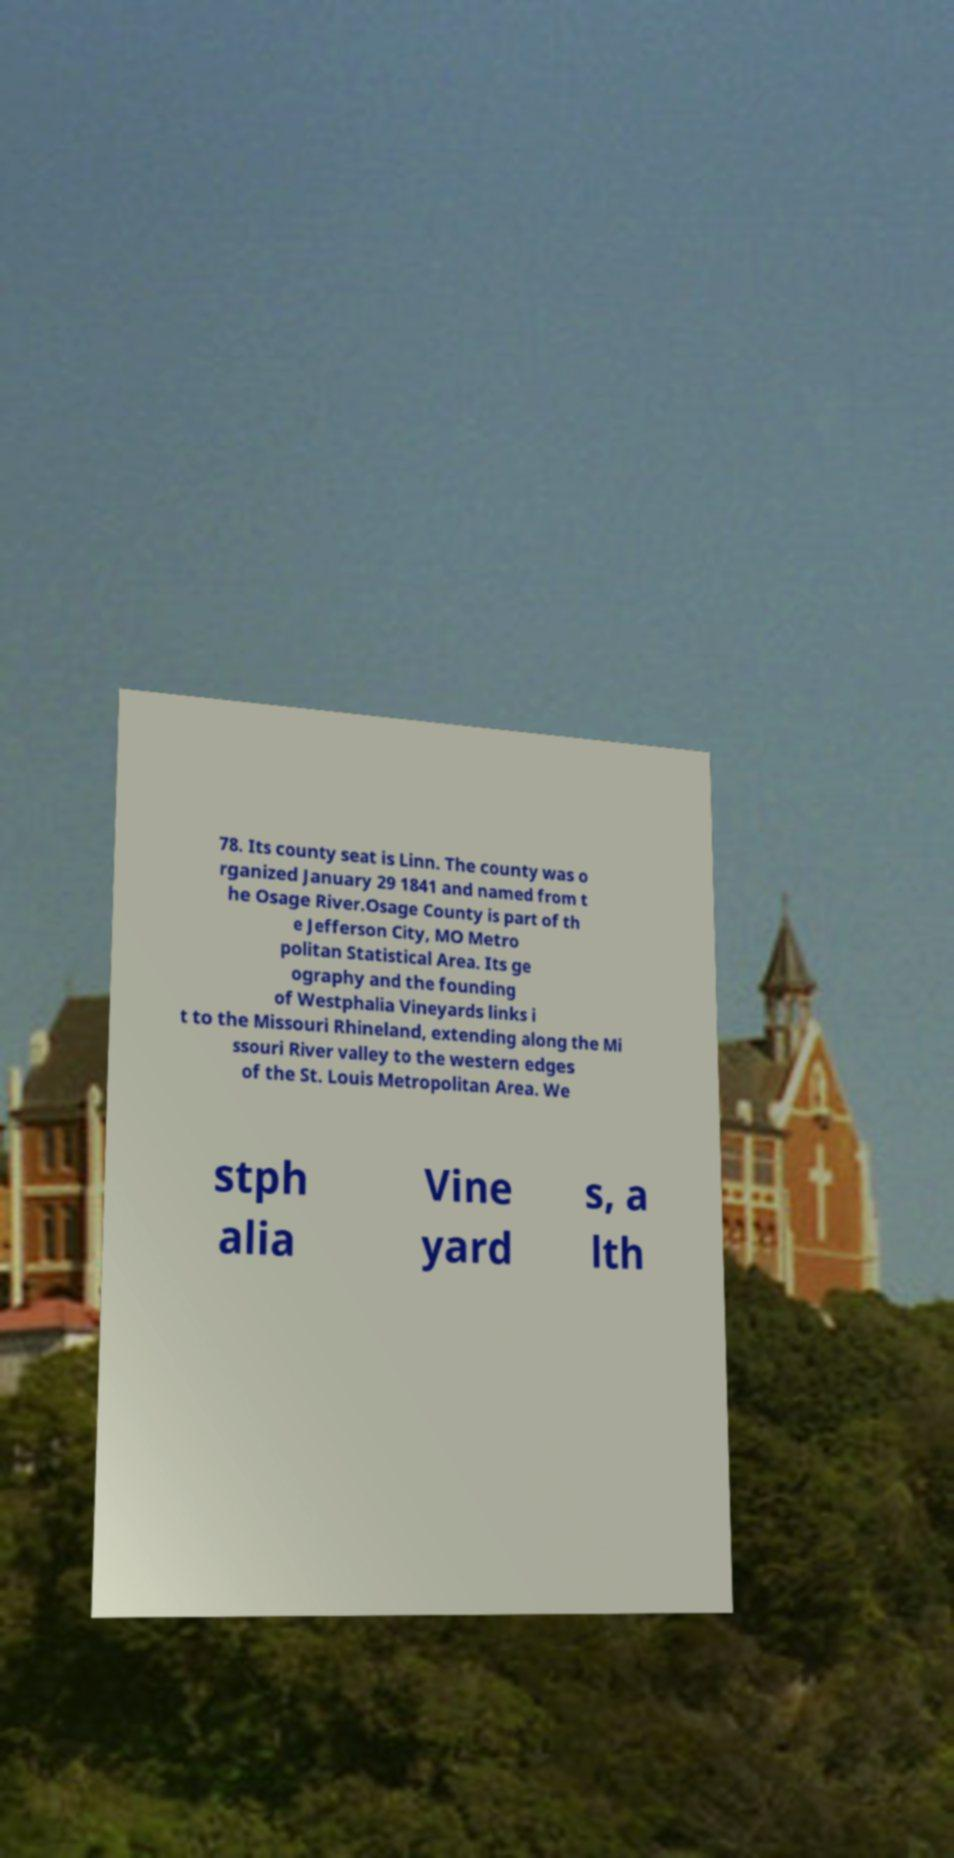For documentation purposes, I need the text within this image transcribed. Could you provide that? 78. Its county seat is Linn. The county was o rganized January 29 1841 and named from t he Osage River.Osage County is part of th e Jefferson City, MO Metro politan Statistical Area. Its ge ography and the founding of Westphalia Vineyards links i t to the Missouri Rhineland, extending along the Mi ssouri River valley to the western edges of the St. Louis Metropolitan Area. We stph alia Vine yard s, a lth 